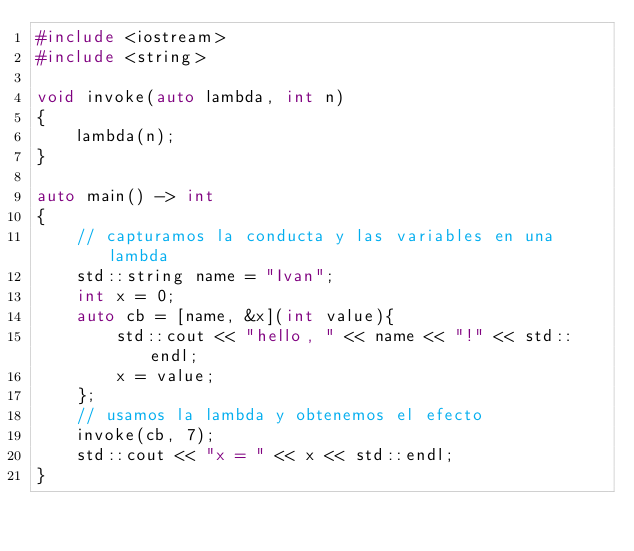Convert code to text. <code><loc_0><loc_0><loc_500><loc_500><_C++_>#include <iostream>
#include <string>

void invoke(auto lambda, int n)
{
	lambda(n);
}

auto main() -> int
{
	// capturamos la conducta y las variables en una lambda
	std::string name = "Ivan";
	int x = 0;
	auto cb = [name, &x](int value){
		std::cout << "hello, " << name << "!" << std::endl;
		x = value;
	};
	// usamos la lambda y obtenemos el efecto
	invoke(cb, 7);
	std::cout << "x = " << x << std::endl;
}



</code> 